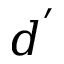<formula> <loc_0><loc_0><loc_500><loc_500>d ^ { ^ { \prime } }</formula> 